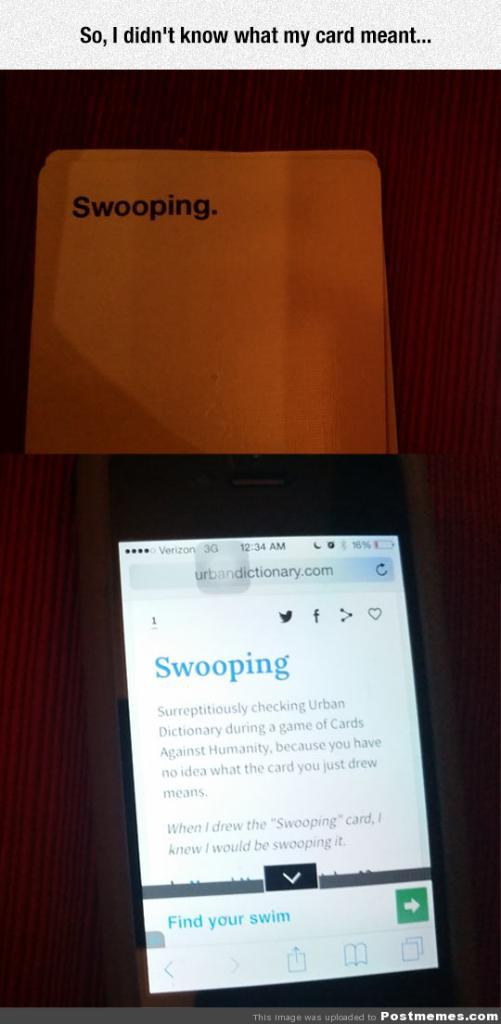What is the main object in the image? There is a small mobile screen in the image. What is displayed on the mobile screen? The word "Scooping" is written on the mobile screen. What page is the flame turning on the mobile screen? There is no flame present on the mobile screen in the image. 